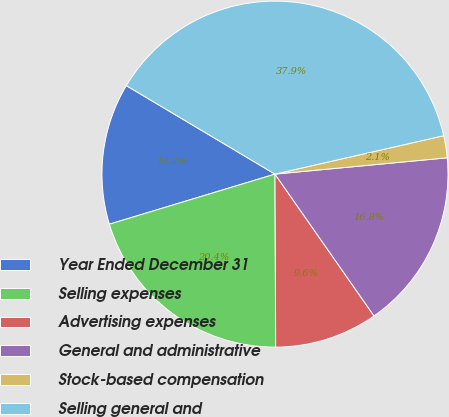Convert chart. <chart><loc_0><loc_0><loc_500><loc_500><pie_chart><fcel>Year Ended December 31<fcel>Selling expenses<fcel>Advertising expenses<fcel>General and administrative<fcel>Stock-based compensation<fcel>Selling general and<nl><fcel>13.22%<fcel>20.39%<fcel>9.64%<fcel>16.8%<fcel>2.06%<fcel>37.89%<nl></chart> 